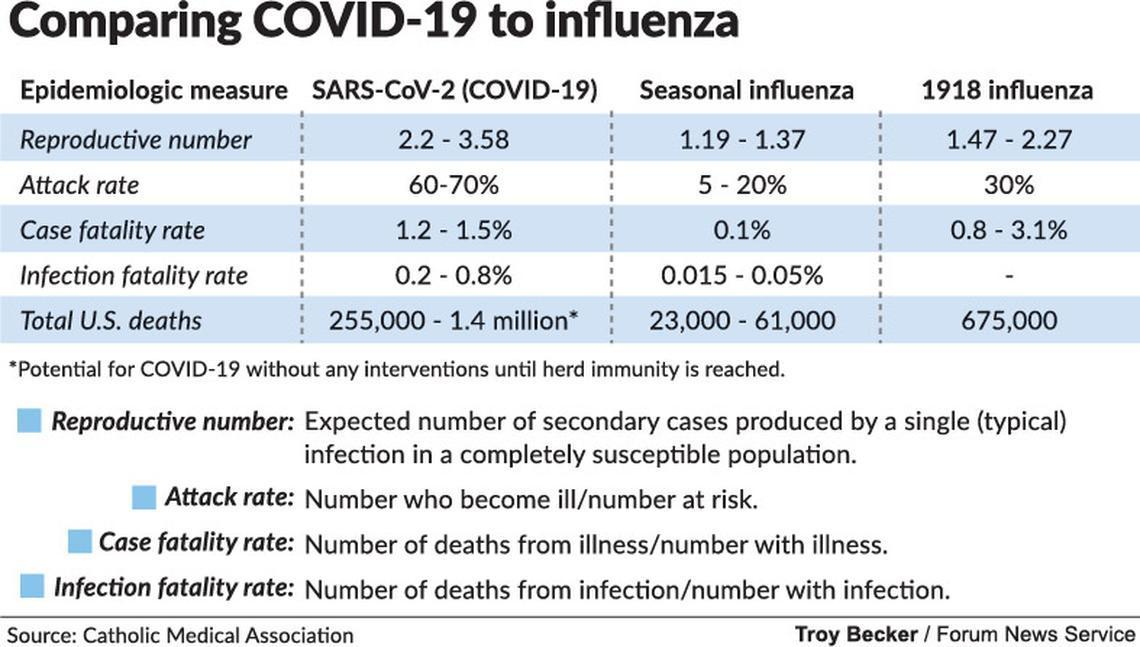What is the total number of deaths in the U.S. caused by 1918 influenza?
Answer the question with a short phrase. 675,000 What is the attack rate of COVID-19 virus? 60-70% What is the total number of COVID-19 deaths in the U.S.? 255,000 - 1.4 million What is the case fatality rate of seasonal influenza? 0.1% What is the reproductive number of COVID-19 virus? 2.2 - 3.58 What is the infection fatality rate of seasonal influenza? 0.015 - 0.05% 